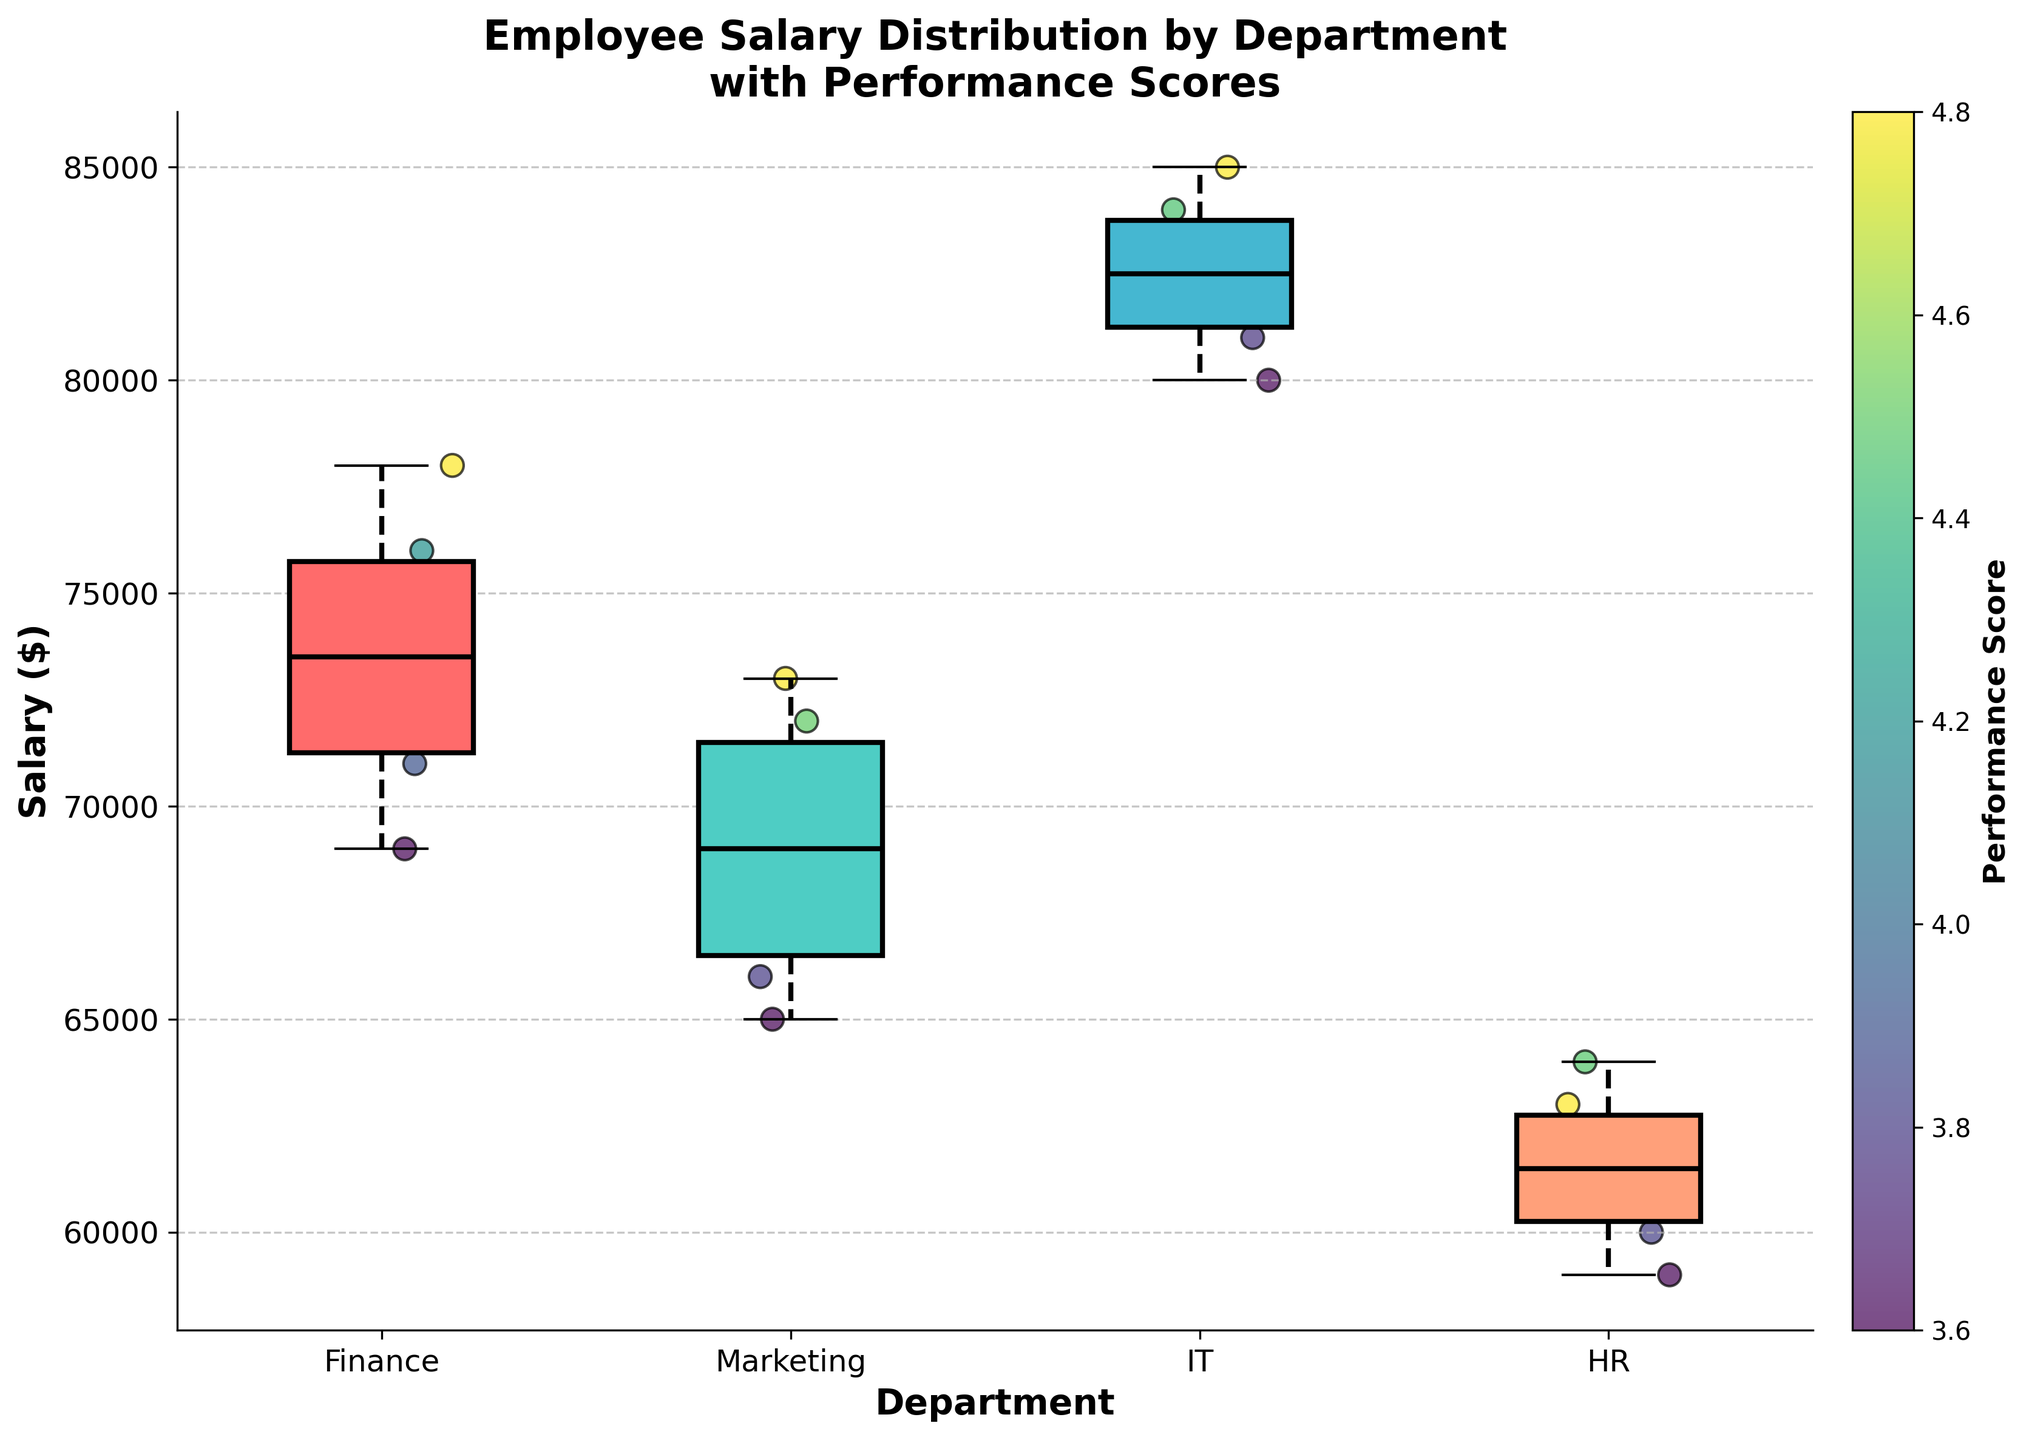What is the title of the figure? The title of the figure is the text displayed at the top of the plot. It usually summarizes the main point of the plot. In this case, the title is given in bold.
Answer: Employee Salary Distribution by Department with Performance Scores How many departments are compared in the figure? Count the different departments represented on the x-axis. These are Finance, Marketing, IT, and HR.
Answer: 4 Which department has the widest range of salaries? Look at the length of the boxes and whiskers for each department. The department with the longest box and whiskers range has the widest salary distribution.
Answer: IT What is the median salary of the Marketing department? Find the midpoint line inside the box for the Marketing department and read its corresponding salary value on the y-axis.
Answer: $70000 Which department has the highest median salary? Compare the median lines (middle line in the box) of all four departments and identify which one is the highest on the y-axis.
Answer: IT Are there any outliers in the HR department's salary distribution? Check if there are any scatter points that lie outside the whiskers of the box plot for the HR department, which would indicate outliers.
Answer: Yes What is the range of performance scores represented by the scatter points? Look at the color bar legend and find the range of values from the lowest to the highest indicated performance scores.
Answer: 2.8 to 4.8 Which department has the most consistently high performance scores based on the scatter points? Observe the color intensity of the scatter points; the department with more points colored in the higher range (towards yellow/green) has the highest performance scores.
Answer: IT Between Finance and Marketing, which department has a higher median salary? Compare the median line (middle line) inside the boxes of Finance and Marketing and see which is higher on the y-axis.
Answer: Finance Which department has the lowest lowest salary? Check the bottom whisker of each department's box plot to find the one that is lowest on the y-axis.
Answer: HR 